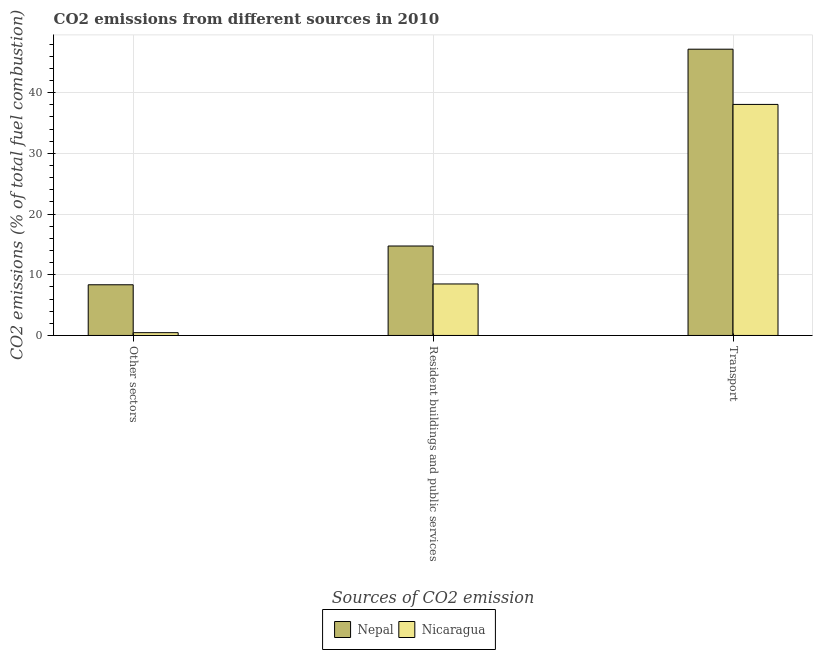How many different coloured bars are there?
Ensure brevity in your answer.  2. How many groups of bars are there?
Provide a short and direct response. 3. Are the number of bars on each tick of the X-axis equal?
Ensure brevity in your answer.  Yes. How many bars are there on the 1st tick from the left?
Ensure brevity in your answer.  2. How many bars are there on the 1st tick from the right?
Provide a succinct answer. 2. What is the label of the 1st group of bars from the left?
Provide a succinct answer. Other sectors. What is the percentage of co2 emissions from other sectors in Nepal?
Provide a succinct answer. 8.35. Across all countries, what is the maximum percentage of co2 emissions from resident buildings and public services?
Give a very brief answer. 14.74. Across all countries, what is the minimum percentage of co2 emissions from other sectors?
Offer a very short reply. 0.46. In which country was the percentage of co2 emissions from resident buildings and public services maximum?
Offer a terse response. Nepal. In which country was the percentage of co2 emissions from resident buildings and public services minimum?
Keep it short and to the point. Nicaragua. What is the total percentage of co2 emissions from other sectors in the graph?
Offer a very short reply. 8.81. What is the difference between the percentage of co2 emissions from transport in Nicaragua and that in Nepal?
Your answer should be compact. -9.1. What is the difference between the percentage of co2 emissions from transport in Nicaragua and the percentage of co2 emissions from resident buildings and public services in Nepal?
Your response must be concise. 23.33. What is the average percentage of co2 emissions from transport per country?
Give a very brief answer. 42.62. What is the difference between the percentage of co2 emissions from resident buildings and public services and percentage of co2 emissions from other sectors in Nepal?
Keep it short and to the point. 6.39. What is the ratio of the percentage of co2 emissions from transport in Nicaragua to that in Nepal?
Offer a terse response. 0.81. Is the percentage of co2 emissions from other sectors in Nicaragua less than that in Nepal?
Your response must be concise. Yes. Is the difference between the percentage of co2 emissions from transport in Nepal and Nicaragua greater than the difference between the percentage of co2 emissions from resident buildings and public services in Nepal and Nicaragua?
Your response must be concise. Yes. What is the difference between the highest and the second highest percentage of co2 emissions from transport?
Keep it short and to the point. 9.1. What is the difference between the highest and the lowest percentage of co2 emissions from other sectors?
Ensure brevity in your answer.  7.9. What does the 2nd bar from the left in Transport represents?
Provide a short and direct response. Nicaragua. What does the 2nd bar from the right in Transport represents?
Your answer should be compact. Nepal. Is it the case that in every country, the sum of the percentage of co2 emissions from other sectors and percentage of co2 emissions from resident buildings and public services is greater than the percentage of co2 emissions from transport?
Provide a short and direct response. No. How many bars are there?
Offer a very short reply. 6. How many countries are there in the graph?
Your answer should be compact. 2. Does the graph contain any zero values?
Keep it short and to the point. No. Does the graph contain grids?
Give a very brief answer. Yes. Where does the legend appear in the graph?
Provide a succinct answer. Bottom center. How many legend labels are there?
Your answer should be very brief. 2. What is the title of the graph?
Give a very brief answer. CO2 emissions from different sources in 2010. Does "Antigua and Barbuda" appear as one of the legend labels in the graph?
Offer a terse response. No. What is the label or title of the X-axis?
Give a very brief answer. Sources of CO2 emission. What is the label or title of the Y-axis?
Offer a terse response. CO2 emissions (% of total fuel combustion). What is the CO2 emissions (% of total fuel combustion) of Nepal in Other sectors?
Ensure brevity in your answer.  8.35. What is the CO2 emissions (% of total fuel combustion) of Nicaragua in Other sectors?
Your answer should be compact. 0.46. What is the CO2 emissions (% of total fuel combustion) of Nepal in Resident buildings and public services?
Ensure brevity in your answer.  14.74. What is the CO2 emissions (% of total fuel combustion) in Nicaragua in Resident buildings and public services?
Keep it short and to the point. 8.49. What is the CO2 emissions (% of total fuel combustion) in Nepal in Transport?
Keep it short and to the point. 47.17. What is the CO2 emissions (% of total fuel combustion) of Nicaragua in Transport?
Provide a succinct answer. 38.07. Across all Sources of CO2 emission, what is the maximum CO2 emissions (% of total fuel combustion) in Nepal?
Your answer should be compact. 47.17. Across all Sources of CO2 emission, what is the maximum CO2 emissions (% of total fuel combustion) in Nicaragua?
Your answer should be very brief. 38.07. Across all Sources of CO2 emission, what is the minimum CO2 emissions (% of total fuel combustion) in Nepal?
Your answer should be very brief. 8.35. Across all Sources of CO2 emission, what is the minimum CO2 emissions (% of total fuel combustion) of Nicaragua?
Offer a very short reply. 0.46. What is the total CO2 emissions (% of total fuel combustion) of Nepal in the graph?
Offer a very short reply. 70.27. What is the total CO2 emissions (% of total fuel combustion) in Nicaragua in the graph?
Ensure brevity in your answer.  47.02. What is the difference between the CO2 emissions (% of total fuel combustion) of Nepal in Other sectors and that in Resident buildings and public services?
Make the answer very short. -6.39. What is the difference between the CO2 emissions (% of total fuel combustion) of Nicaragua in Other sectors and that in Resident buildings and public services?
Offer a terse response. -8.03. What is the difference between the CO2 emissions (% of total fuel combustion) in Nepal in Other sectors and that in Transport?
Make the answer very short. -38.82. What is the difference between the CO2 emissions (% of total fuel combustion) of Nicaragua in Other sectors and that in Transport?
Offer a terse response. -37.61. What is the difference between the CO2 emissions (% of total fuel combustion) in Nepal in Resident buildings and public services and that in Transport?
Keep it short and to the point. -32.43. What is the difference between the CO2 emissions (% of total fuel combustion) of Nicaragua in Resident buildings and public services and that in Transport?
Give a very brief answer. -29.59. What is the difference between the CO2 emissions (% of total fuel combustion) of Nepal in Other sectors and the CO2 emissions (% of total fuel combustion) of Nicaragua in Resident buildings and public services?
Provide a succinct answer. -0.13. What is the difference between the CO2 emissions (% of total fuel combustion) in Nepal in Other sectors and the CO2 emissions (% of total fuel combustion) in Nicaragua in Transport?
Offer a very short reply. -29.72. What is the difference between the CO2 emissions (% of total fuel combustion) of Nepal in Resident buildings and public services and the CO2 emissions (% of total fuel combustion) of Nicaragua in Transport?
Offer a terse response. -23.33. What is the average CO2 emissions (% of total fuel combustion) of Nepal per Sources of CO2 emission?
Offer a very short reply. 23.42. What is the average CO2 emissions (% of total fuel combustion) of Nicaragua per Sources of CO2 emission?
Give a very brief answer. 15.67. What is the difference between the CO2 emissions (% of total fuel combustion) in Nepal and CO2 emissions (% of total fuel combustion) in Nicaragua in Other sectors?
Provide a short and direct response. 7.9. What is the difference between the CO2 emissions (% of total fuel combustion) of Nepal and CO2 emissions (% of total fuel combustion) of Nicaragua in Resident buildings and public services?
Give a very brief answer. 6.26. What is the difference between the CO2 emissions (% of total fuel combustion) of Nepal and CO2 emissions (% of total fuel combustion) of Nicaragua in Transport?
Your answer should be compact. 9.1. What is the ratio of the CO2 emissions (% of total fuel combustion) of Nepal in Other sectors to that in Resident buildings and public services?
Provide a short and direct response. 0.57. What is the ratio of the CO2 emissions (% of total fuel combustion) in Nicaragua in Other sectors to that in Resident buildings and public services?
Offer a terse response. 0.05. What is the ratio of the CO2 emissions (% of total fuel combustion) in Nepal in Other sectors to that in Transport?
Ensure brevity in your answer.  0.18. What is the ratio of the CO2 emissions (% of total fuel combustion) in Nicaragua in Other sectors to that in Transport?
Offer a terse response. 0.01. What is the ratio of the CO2 emissions (% of total fuel combustion) of Nepal in Resident buildings and public services to that in Transport?
Your response must be concise. 0.31. What is the ratio of the CO2 emissions (% of total fuel combustion) in Nicaragua in Resident buildings and public services to that in Transport?
Give a very brief answer. 0.22. What is the difference between the highest and the second highest CO2 emissions (% of total fuel combustion) of Nepal?
Offer a very short reply. 32.43. What is the difference between the highest and the second highest CO2 emissions (% of total fuel combustion) of Nicaragua?
Your answer should be compact. 29.59. What is the difference between the highest and the lowest CO2 emissions (% of total fuel combustion) in Nepal?
Give a very brief answer. 38.82. What is the difference between the highest and the lowest CO2 emissions (% of total fuel combustion) in Nicaragua?
Your answer should be compact. 37.61. 